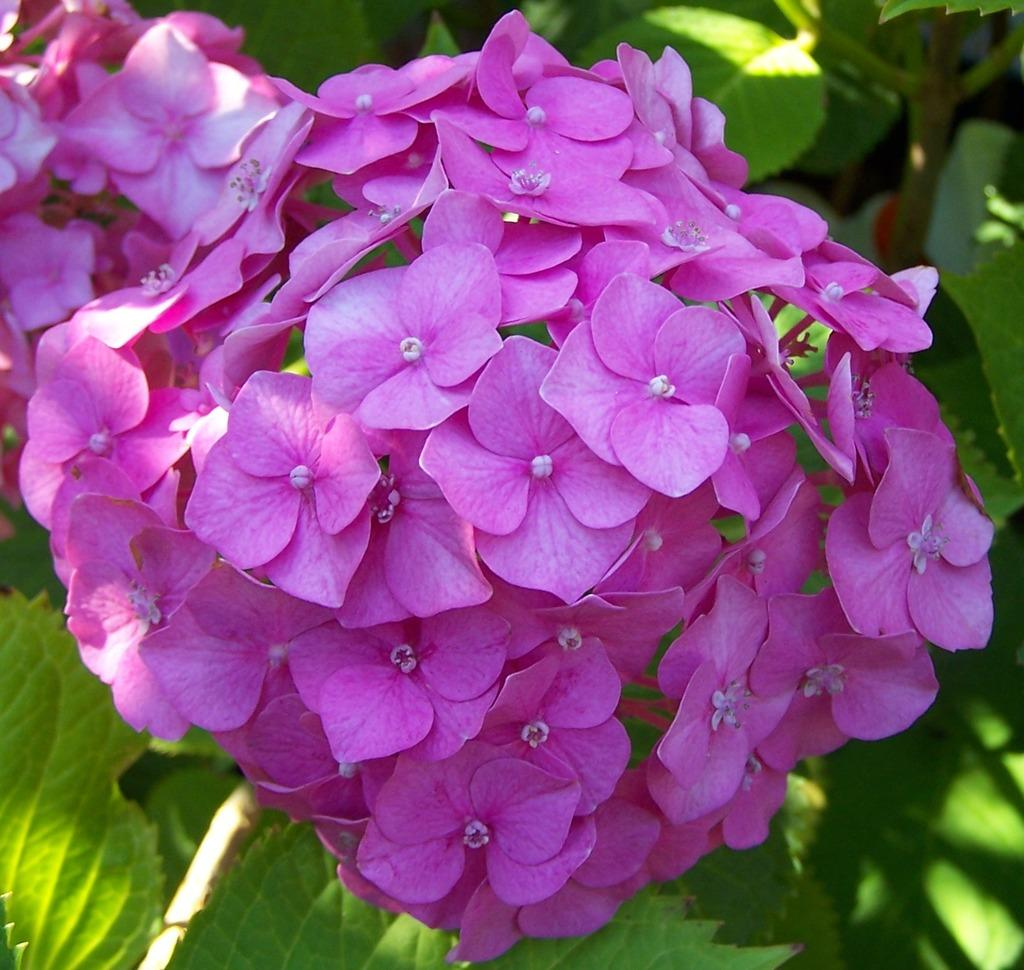What type of flowers can be seen in the image? There are purple flowers in the image. Where are the flowers located? The flowers are on a plant. What type of metal is used to make the kettle in the image? There is no kettle present in the image, so it is not possible to determine the type of metal used. 